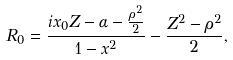<formula> <loc_0><loc_0><loc_500><loc_500>R _ { 0 } = \frac { i x _ { 0 } Z - \alpha - \frac { \rho ^ { 2 } } { 2 } } { 1 - x ^ { 2 } } - \frac { Z ^ { 2 } - \rho ^ { 2 } } { 2 } ,</formula> 